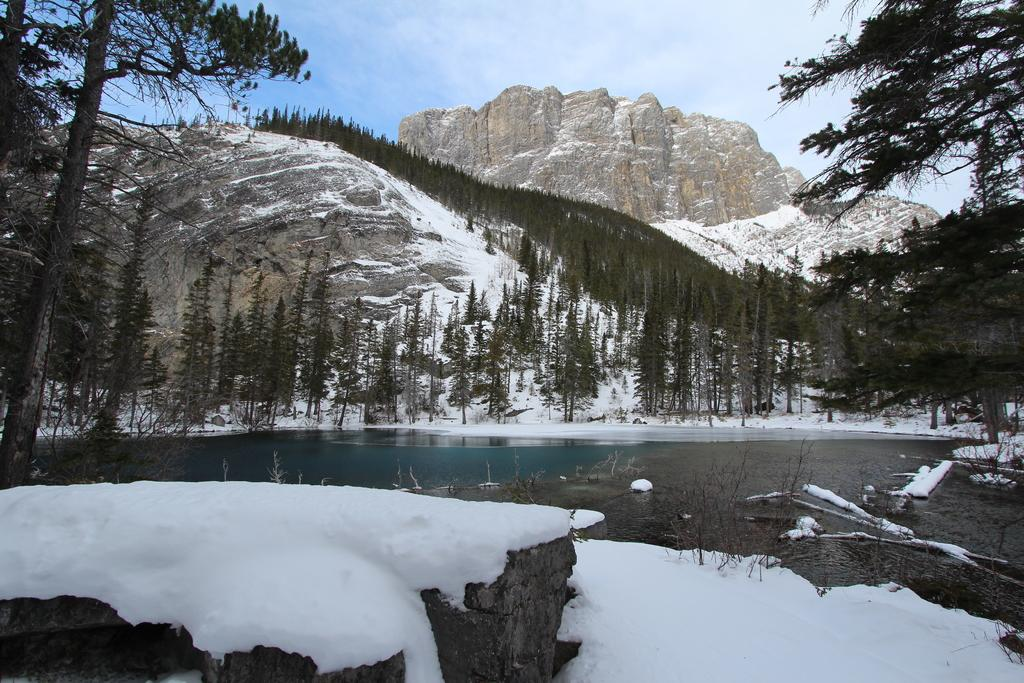What type of weather condition is depicted in the image? There is snow on the surface in the image, indicating a winter-like condition. What is the main feature of the image? The main feature of the image is water. What can be seen in the background of the image? There are trees and mountains in the background of the image, as well as the sky. What type of tools does the carpenter use in the image? There is no carpenter present in the image, so it is not possible to determine what tools they might use. 